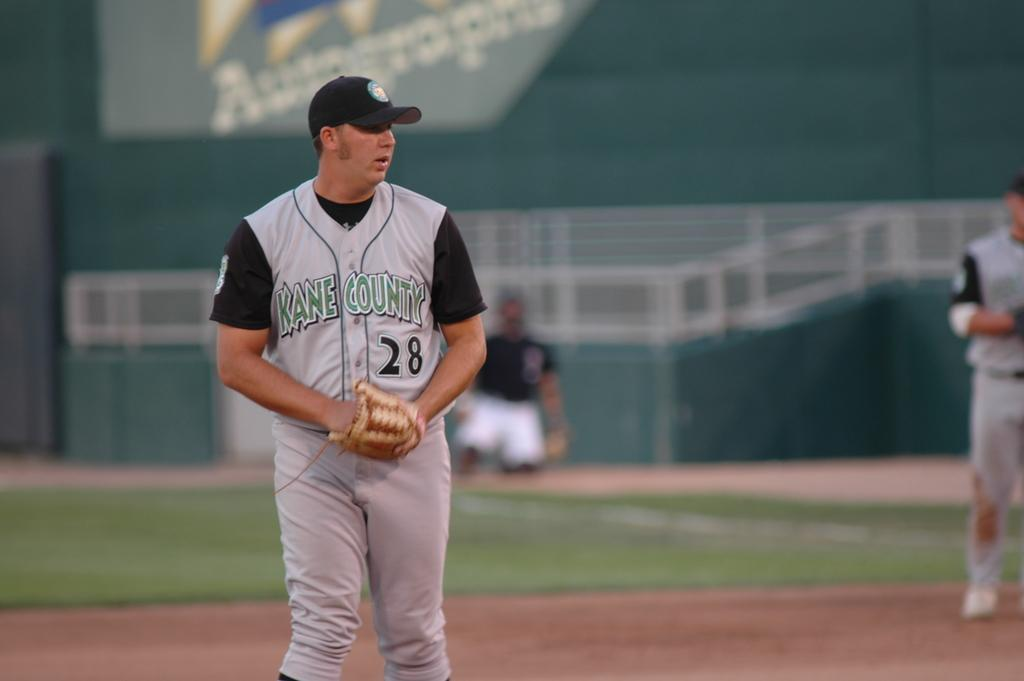<image>
Render a clear and concise summary of the photo. a player that has the number 28 on their baseball jersey 